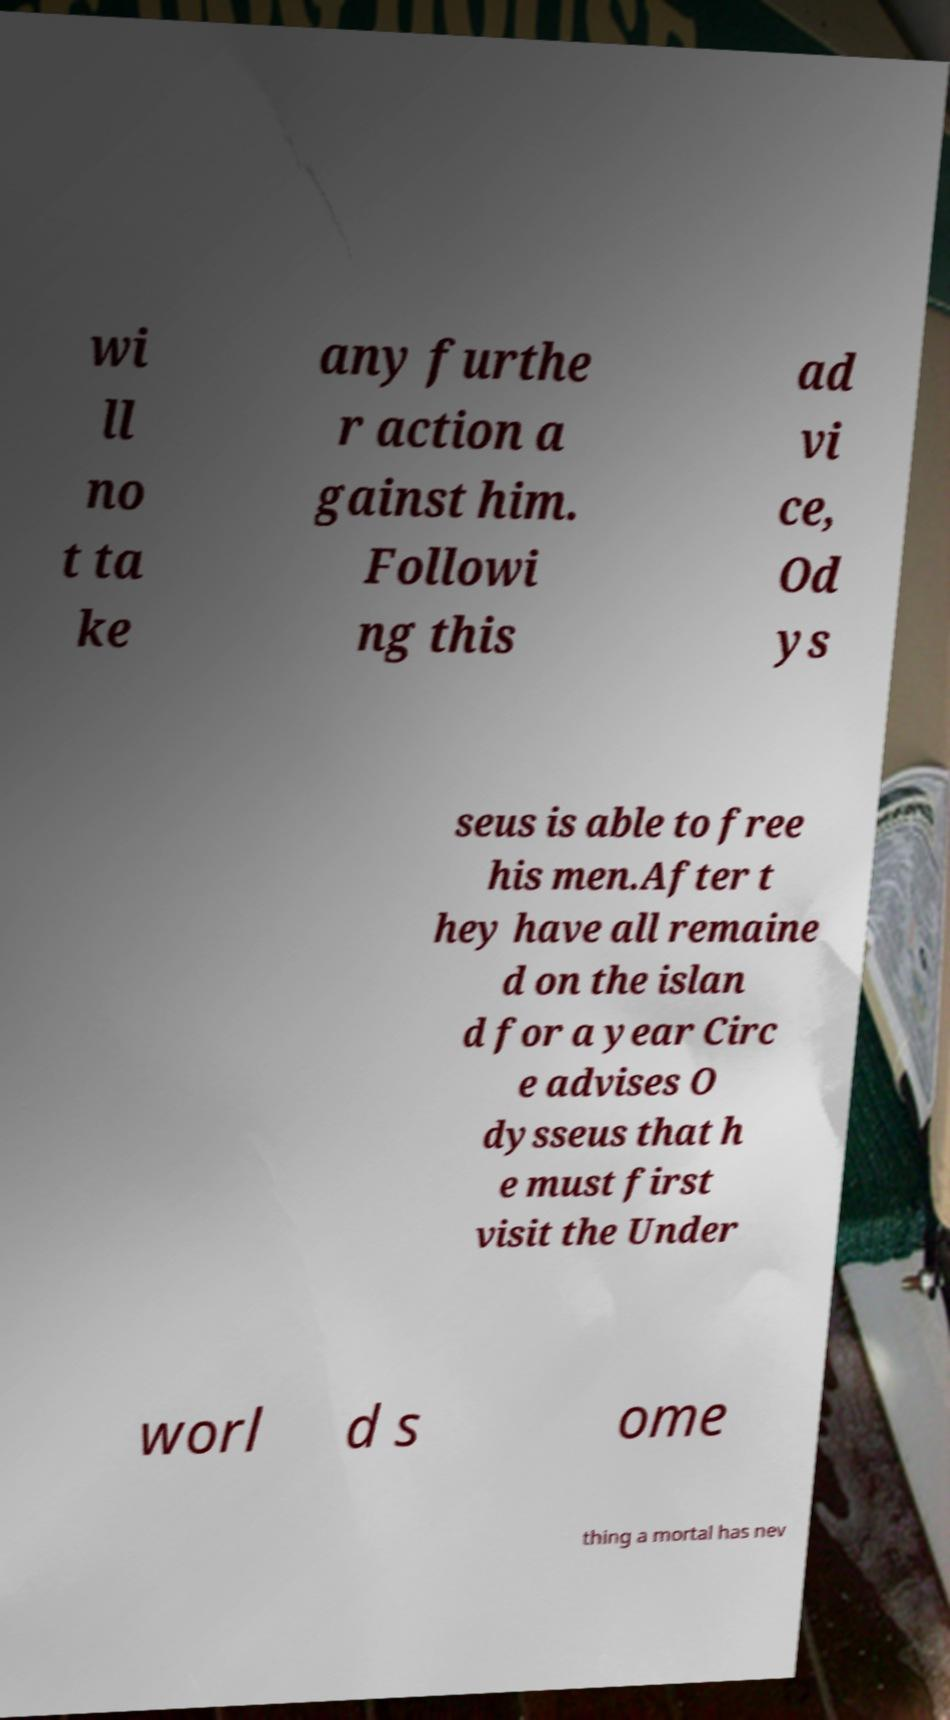What messages or text are displayed in this image? I need them in a readable, typed format. wi ll no t ta ke any furthe r action a gainst him. Followi ng this ad vi ce, Od ys seus is able to free his men.After t hey have all remaine d on the islan d for a year Circ e advises O dysseus that h e must first visit the Under worl d s ome thing a mortal has nev 